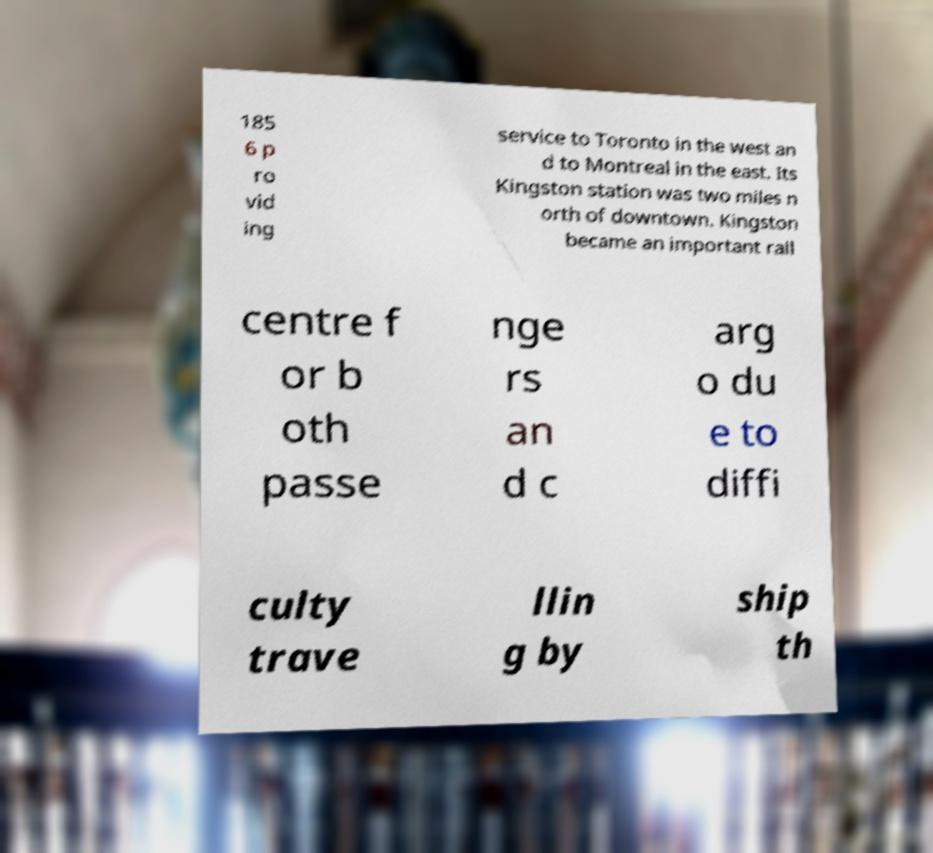Could you extract and type out the text from this image? 185 6 p ro vid ing service to Toronto in the west an d to Montreal in the east. Its Kingston station was two miles n orth of downtown. Kingston became an important rail centre f or b oth passe nge rs an d c arg o du e to diffi culty trave llin g by ship th 